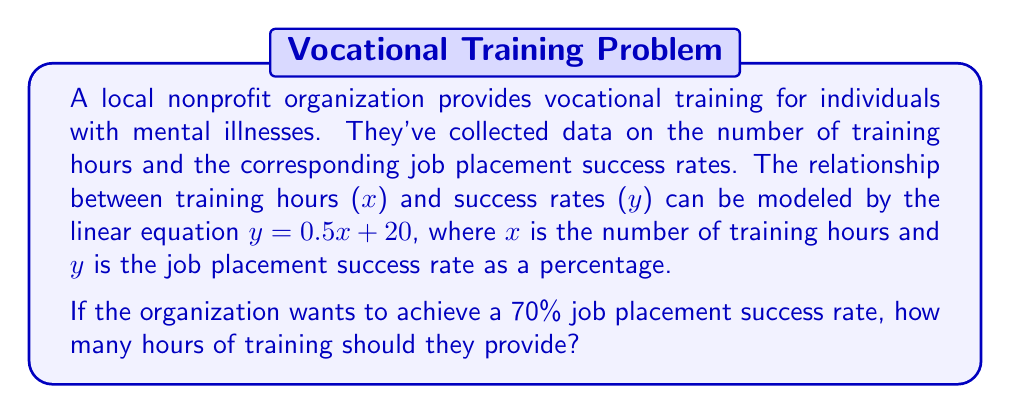Give your solution to this math problem. To solve this problem, we need to use the given linear equation and substitute the desired success rate. Then, we'll solve for the number of training hours.

1. Given equation: $y = 0.5x + 20$
2. Desired success rate: $y = 70\%$

Let's substitute $y = 70$ into the equation:

$$70 = 0.5x + 20$$

Now, we need to solve for $x$:

3. Subtract 20 from both sides:
   $$70 - 20 = 0.5x + 20 - 20$$
   $$50 = 0.5x$$

4. Multiply both sides by 2 to isolate $x$:
   $$2 \cdot 50 = 2 \cdot 0.5x$$
   $$100 = x$$

Therefore, the organization should provide 100 hours of training to achieve a 70% job placement success rate.
Answer: 100 hours 